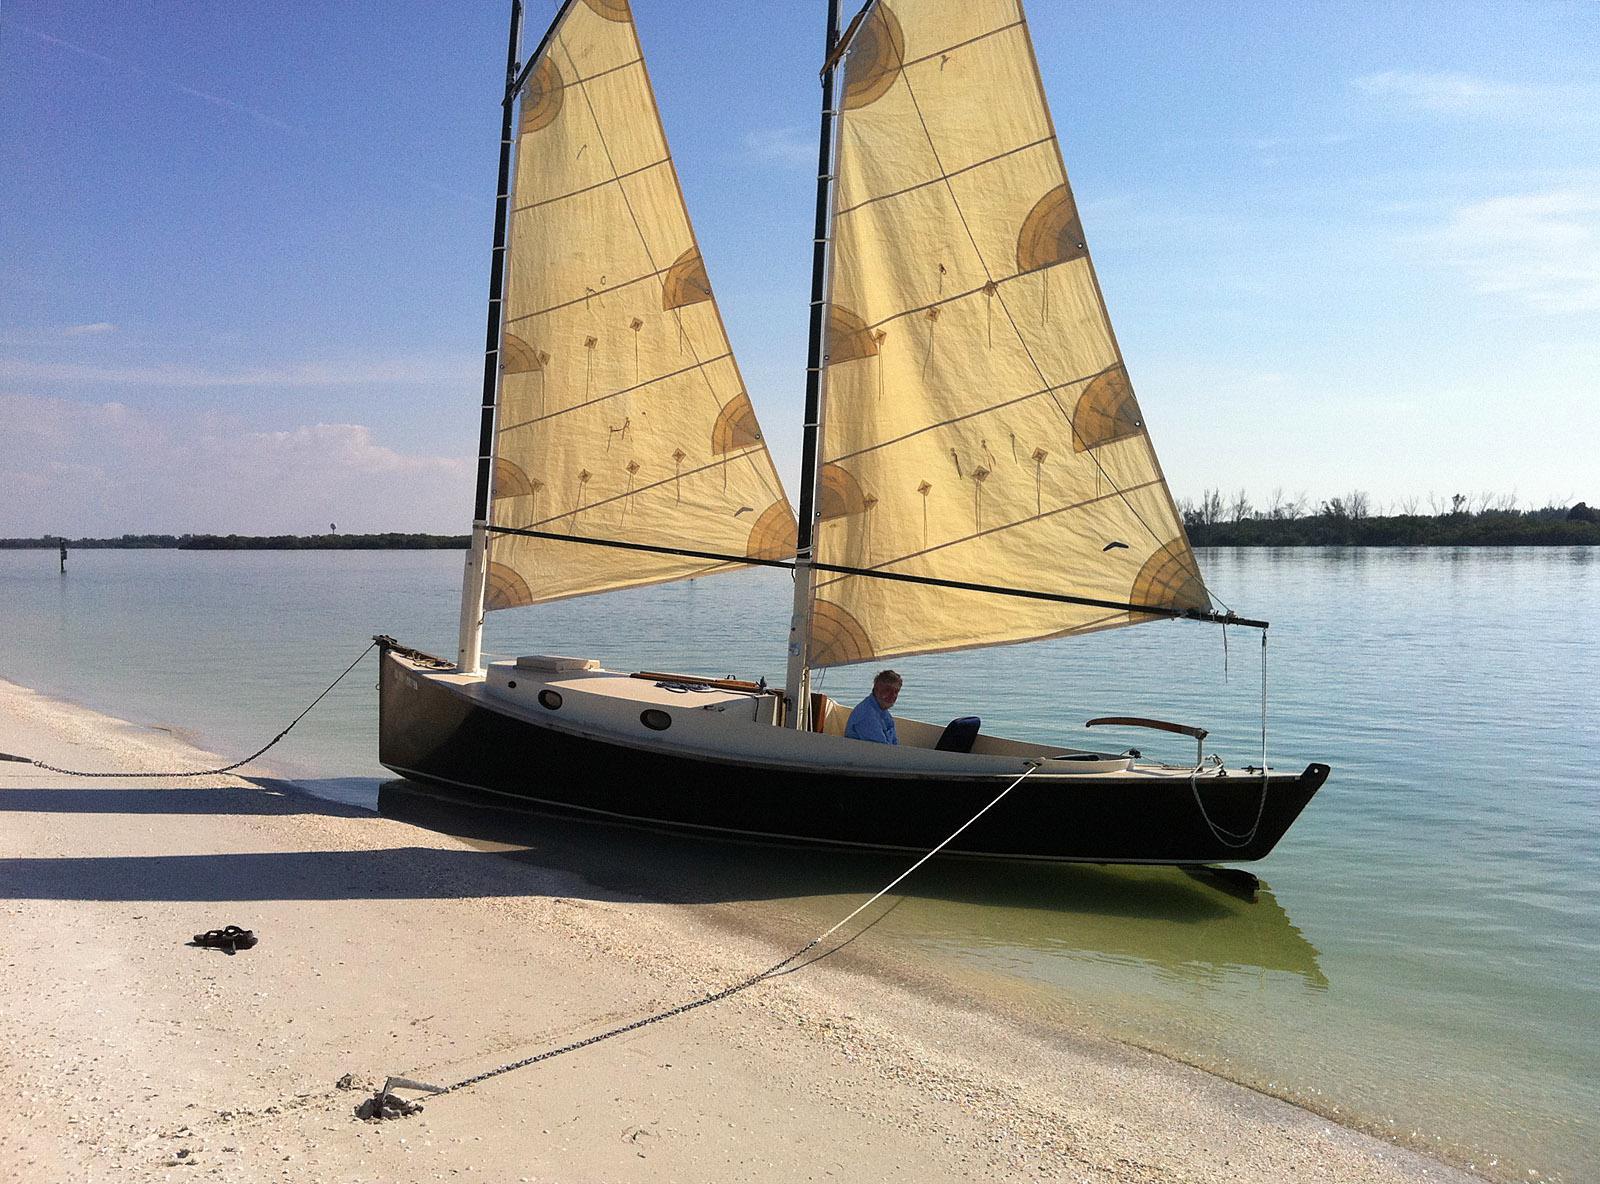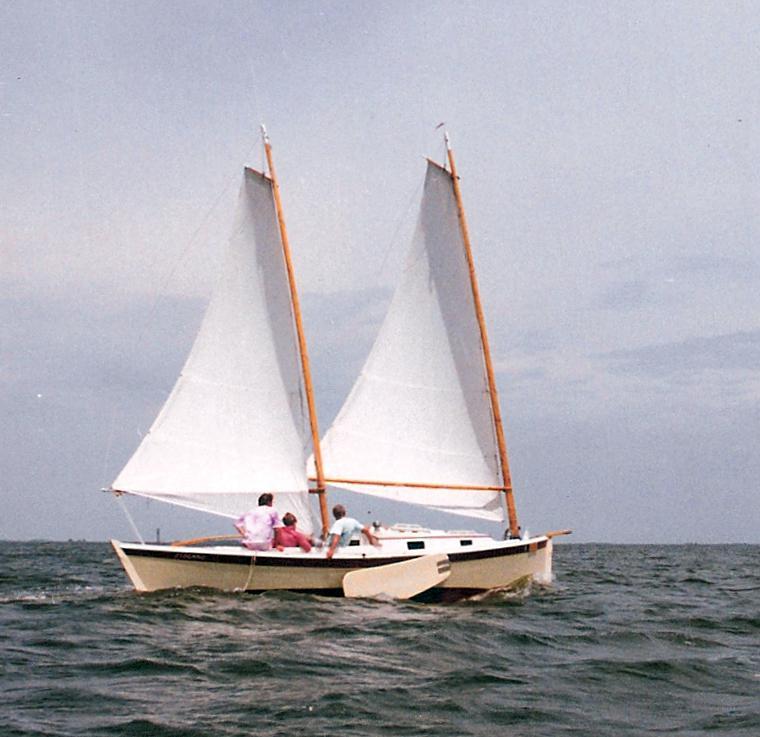The first image is the image on the left, the second image is the image on the right. Considering the images on both sides, is "There is at least one human onboard each boat." valid? Answer yes or no. Yes. 